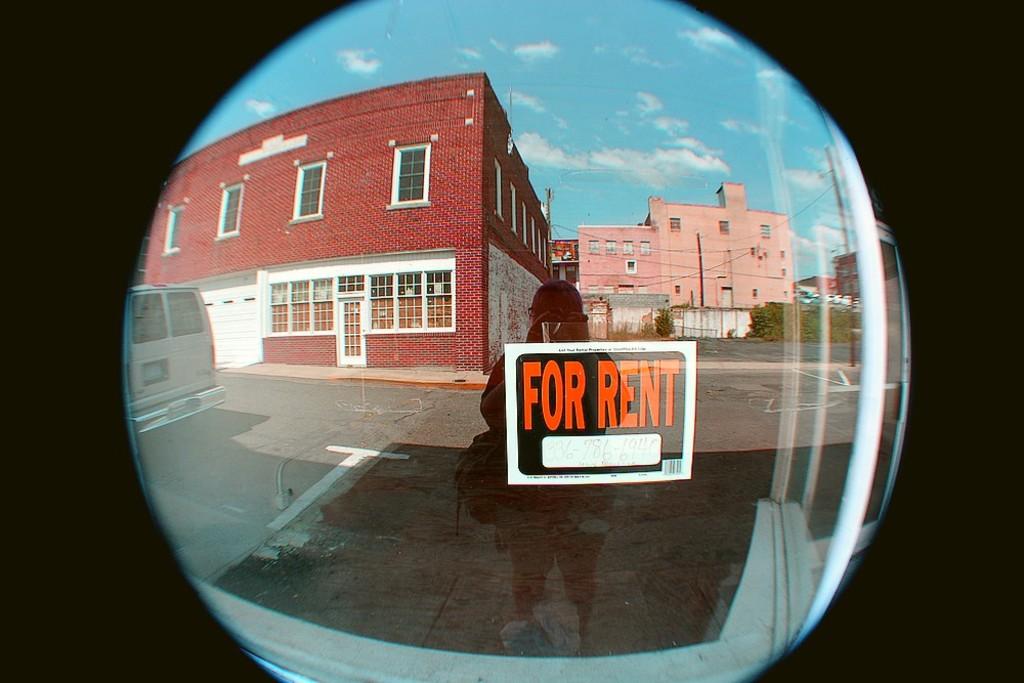Is there a number to call on the for rent sign?
Make the answer very short. No. This storefront is for what?
Make the answer very short. Rent. 